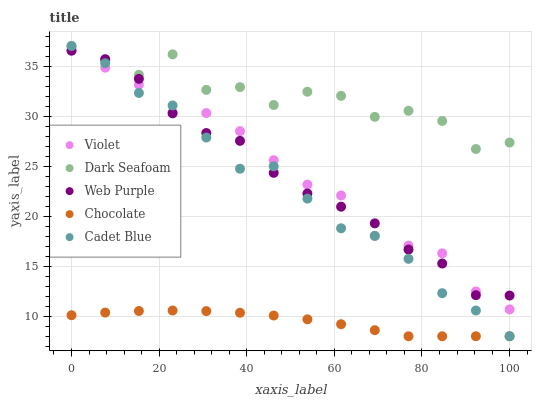Does Chocolate have the minimum area under the curve?
Answer yes or no. Yes. Does Dark Seafoam have the maximum area under the curve?
Answer yes or no. Yes. Does Dark Seafoam have the minimum area under the curve?
Answer yes or no. No. Does Chocolate have the maximum area under the curve?
Answer yes or no. No. Is Chocolate the smoothest?
Answer yes or no. Yes. Is Dark Seafoam the roughest?
Answer yes or no. Yes. Is Dark Seafoam the smoothest?
Answer yes or no. No. Is Chocolate the roughest?
Answer yes or no. No. Does Cadet Blue have the lowest value?
Answer yes or no. Yes. Does Dark Seafoam have the lowest value?
Answer yes or no. No. Does Dark Seafoam have the highest value?
Answer yes or no. Yes. Does Chocolate have the highest value?
Answer yes or no. No. Is Chocolate less than Web Purple?
Answer yes or no. Yes. Is Dark Seafoam greater than Violet?
Answer yes or no. Yes. Does Web Purple intersect Cadet Blue?
Answer yes or no. Yes. Is Web Purple less than Cadet Blue?
Answer yes or no. No. Is Web Purple greater than Cadet Blue?
Answer yes or no. No. Does Chocolate intersect Web Purple?
Answer yes or no. No. 